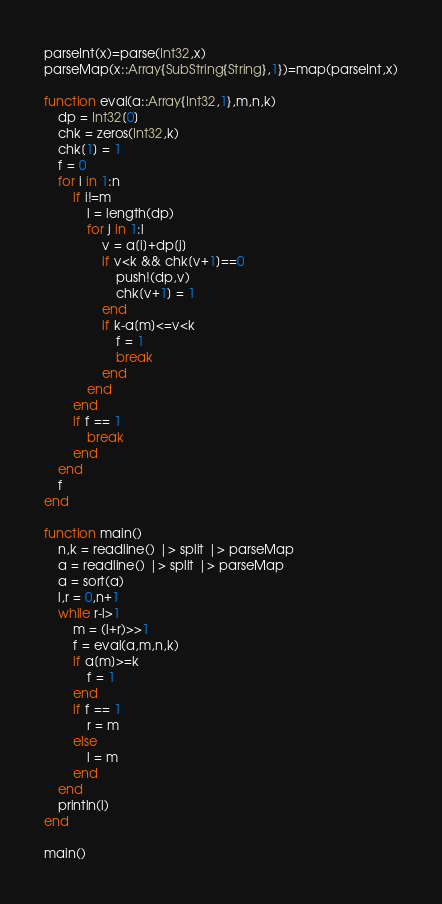Convert code to text. <code><loc_0><loc_0><loc_500><loc_500><_Julia_>parseInt(x)=parse(Int32,x)
parseMap(x::Array{SubString{String},1})=map(parseInt,x)

function eval(a::Array{Int32,1},m,n,k)
	dp = Int32[0]
	chk = zeros(Int32,k)
	chk[1] = 1
	f = 0
	for i in 1:n
		if i!=m
			l = length(dp)
			for j in 1:l
				v = a[i]+dp[j]
				if v<k && chk[v+1]==0
					push!(dp,v)
					chk[v+1] = 1
				end
				if k-a[m]<=v<k
					f = 1
					break
				end
			end
		end
		if f == 1
			break
		end
	end
	f
end

function main()
	n,k = readline() |> split |> parseMap
	a = readline() |> split |> parseMap
	a = sort(a)
	l,r = 0,n+1
	while r-l>1
		m = (l+r)>>1
		f = eval(a,m,n,k)
		if a[m]>=k
			f = 1
		end
		if f == 1
			r = m
		else
			l = m
		end
	end
	println(l)
end

main()</code> 